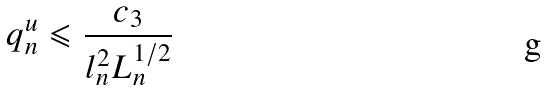<formula> <loc_0><loc_0><loc_500><loc_500>q ^ { u } _ { n } \leqslant \frac { c _ { 3 } } { l ^ { 2 } _ { n } L ^ { 1 / 2 } _ { n } }</formula> 